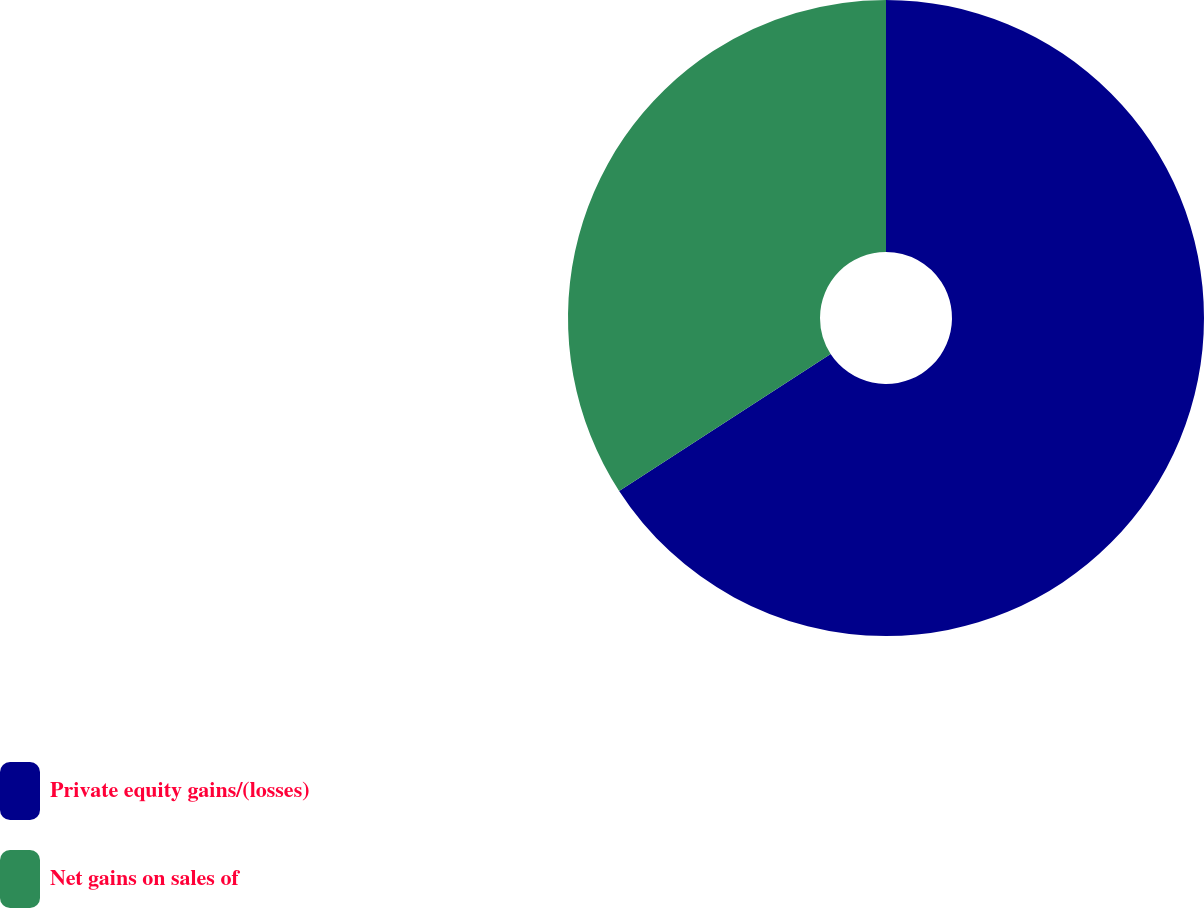Convert chart. <chart><loc_0><loc_0><loc_500><loc_500><pie_chart><fcel>Private equity gains/(losses)<fcel>Net gains on sales of<nl><fcel>65.85%<fcel>34.15%<nl></chart> 